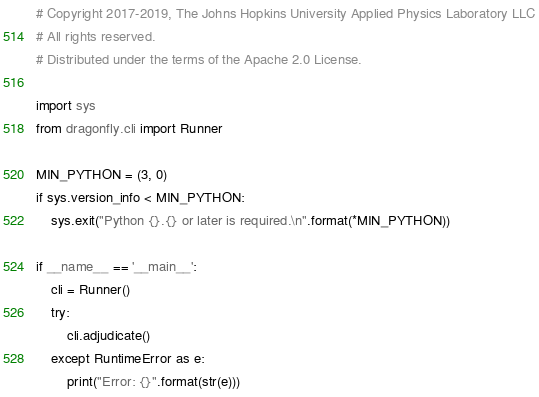Convert code to text. <code><loc_0><loc_0><loc_500><loc_500><_Python_># Copyright 2017-2019, The Johns Hopkins University Applied Physics Laboratory LLC
# All rights reserved.
# Distributed under the terms of the Apache 2.0 License.

import sys
from dragonfly.cli import Runner

MIN_PYTHON = (3, 0)
if sys.version_info < MIN_PYTHON:
    sys.exit("Python {}.{} or later is required.\n".format(*MIN_PYTHON))

if __name__ == '__main__':
    cli = Runner()
    try:
        cli.adjudicate()
    except RuntimeError as e:
        print("Error: {}".format(str(e)))
</code> 